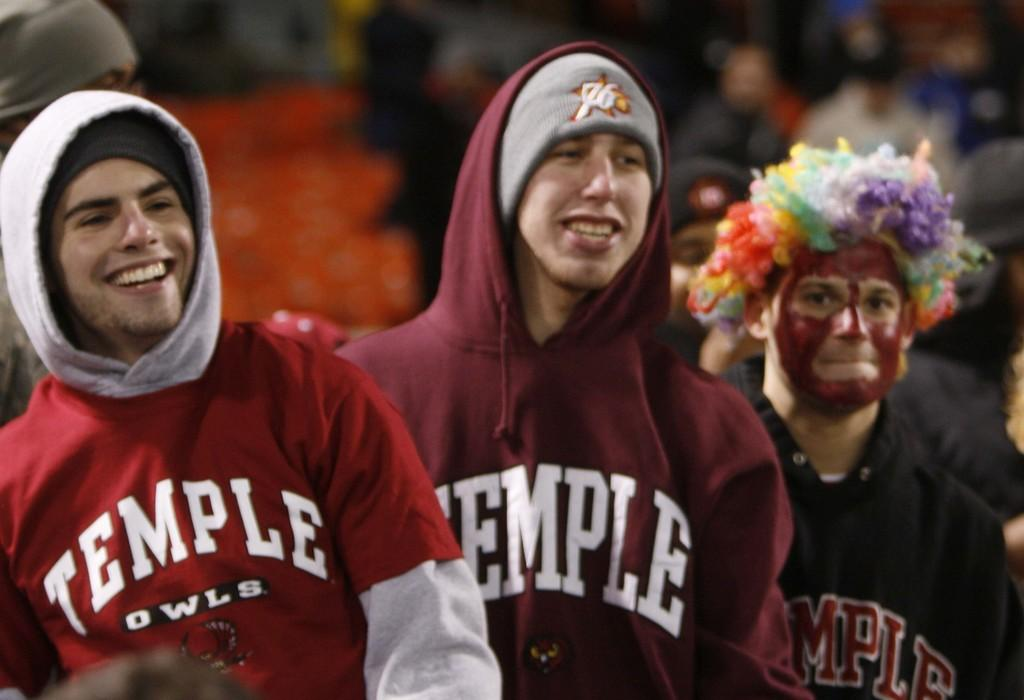<image>
Describe the image concisely. Fans with sweatshirts on that has Temple Owls in white letters. 